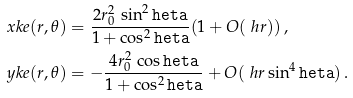<formula> <loc_0><loc_0><loc_500><loc_500>\ x k e ( r , \theta ) & = \frac { 2 r _ { 0 } ^ { 2 } \, \sin ^ { 2 } \tt h e t a } { 1 + \cos ^ { 2 } \tt h e t a } ( 1 + O ( \ h r ) ) \, , \\ \ y k e ( r , \theta ) & = - \frac { 4 r _ { 0 } ^ { 2 } \, \cos \tt h e t a } { 1 + \cos ^ { 2 } \tt h e t a } + O ( \ h r \sin ^ { 4 } \tt h e t a ) \, .</formula> 